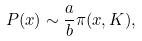Convert formula to latex. <formula><loc_0><loc_0><loc_500><loc_500>P ( x ) \sim \frac { a } { b } \pi ( x , K ) ,</formula> 